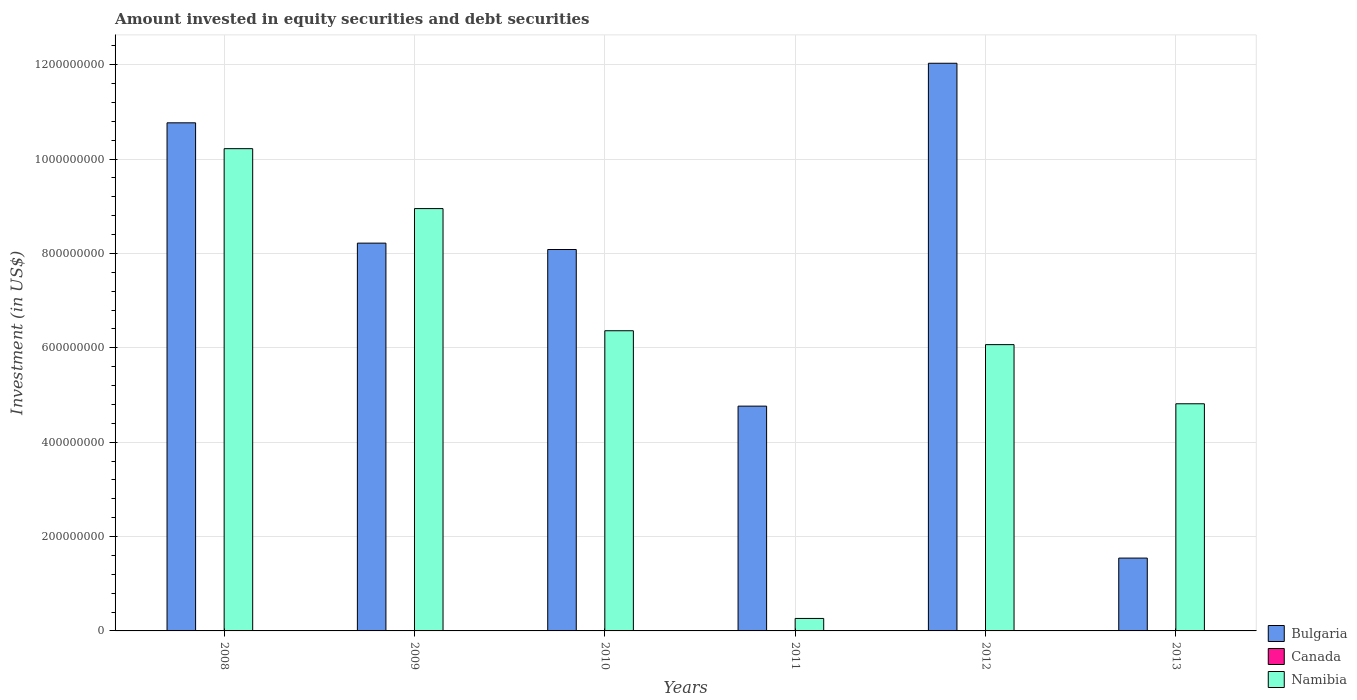How many different coloured bars are there?
Your answer should be very brief. 2. How many groups of bars are there?
Offer a very short reply. 6. Are the number of bars per tick equal to the number of legend labels?
Provide a succinct answer. No. How many bars are there on the 4th tick from the left?
Keep it short and to the point. 2. What is the label of the 1st group of bars from the left?
Offer a very short reply. 2008. Across all years, what is the maximum amount invested in equity securities and debt securities in Bulgaria?
Offer a terse response. 1.20e+09. Across all years, what is the minimum amount invested in equity securities and debt securities in Bulgaria?
Offer a very short reply. 1.54e+08. In which year was the amount invested in equity securities and debt securities in Bulgaria maximum?
Your answer should be compact. 2012. What is the total amount invested in equity securities and debt securities in Bulgaria in the graph?
Keep it short and to the point. 4.54e+09. What is the difference between the amount invested in equity securities and debt securities in Namibia in 2009 and that in 2012?
Your response must be concise. 2.88e+08. What is the difference between the amount invested in equity securities and debt securities in Bulgaria in 2011 and the amount invested in equity securities and debt securities in Canada in 2013?
Give a very brief answer. 4.76e+08. What is the average amount invested in equity securities and debt securities in Bulgaria per year?
Ensure brevity in your answer.  7.57e+08. In the year 2008, what is the difference between the amount invested in equity securities and debt securities in Namibia and amount invested in equity securities and debt securities in Bulgaria?
Your response must be concise. -5.48e+07. What is the ratio of the amount invested in equity securities and debt securities in Namibia in 2008 to that in 2011?
Offer a terse response. 38.63. What is the difference between the highest and the second highest amount invested in equity securities and debt securities in Namibia?
Keep it short and to the point. 1.27e+08. What is the difference between the highest and the lowest amount invested in equity securities and debt securities in Bulgaria?
Make the answer very short. 1.05e+09. Is the sum of the amount invested in equity securities and debt securities in Namibia in 2011 and 2013 greater than the maximum amount invested in equity securities and debt securities in Bulgaria across all years?
Give a very brief answer. No. Are all the bars in the graph horizontal?
Provide a short and direct response. No. How many years are there in the graph?
Offer a very short reply. 6. Are the values on the major ticks of Y-axis written in scientific E-notation?
Give a very brief answer. No. Where does the legend appear in the graph?
Offer a very short reply. Bottom right. What is the title of the graph?
Offer a very short reply. Amount invested in equity securities and debt securities. Does "Morocco" appear as one of the legend labels in the graph?
Your answer should be compact. No. What is the label or title of the Y-axis?
Give a very brief answer. Investment (in US$). What is the Investment (in US$) in Bulgaria in 2008?
Give a very brief answer. 1.08e+09. What is the Investment (in US$) in Canada in 2008?
Make the answer very short. 0. What is the Investment (in US$) of Namibia in 2008?
Make the answer very short. 1.02e+09. What is the Investment (in US$) of Bulgaria in 2009?
Your response must be concise. 8.22e+08. What is the Investment (in US$) of Namibia in 2009?
Give a very brief answer. 8.95e+08. What is the Investment (in US$) of Bulgaria in 2010?
Make the answer very short. 8.08e+08. What is the Investment (in US$) of Namibia in 2010?
Offer a terse response. 6.36e+08. What is the Investment (in US$) in Bulgaria in 2011?
Provide a short and direct response. 4.76e+08. What is the Investment (in US$) in Namibia in 2011?
Your answer should be compact. 2.65e+07. What is the Investment (in US$) of Bulgaria in 2012?
Your response must be concise. 1.20e+09. What is the Investment (in US$) of Canada in 2012?
Provide a short and direct response. 0. What is the Investment (in US$) of Namibia in 2012?
Offer a very short reply. 6.07e+08. What is the Investment (in US$) of Bulgaria in 2013?
Make the answer very short. 1.54e+08. What is the Investment (in US$) in Namibia in 2013?
Keep it short and to the point. 4.81e+08. Across all years, what is the maximum Investment (in US$) of Bulgaria?
Provide a short and direct response. 1.20e+09. Across all years, what is the maximum Investment (in US$) in Namibia?
Provide a short and direct response. 1.02e+09. Across all years, what is the minimum Investment (in US$) in Bulgaria?
Ensure brevity in your answer.  1.54e+08. Across all years, what is the minimum Investment (in US$) in Namibia?
Make the answer very short. 2.65e+07. What is the total Investment (in US$) of Bulgaria in the graph?
Give a very brief answer. 4.54e+09. What is the total Investment (in US$) in Namibia in the graph?
Your answer should be very brief. 3.67e+09. What is the difference between the Investment (in US$) of Bulgaria in 2008 and that in 2009?
Keep it short and to the point. 2.55e+08. What is the difference between the Investment (in US$) of Namibia in 2008 and that in 2009?
Your response must be concise. 1.27e+08. What is the difference between the Investment (in US$) in Bulgaria in 2008 and that in 2010?
Make the answer very short. 2.68e+08. What is the difference between the Investment (in US$) in Namibia in 2008 and that in 2010?
Provide a succinct answer. 3.86e+08. What is the difference between the Investment (in US$) of Bulgaria in 2008 and that in 2011?
Keep it short and to the point. 6.00e+08. What is the difference between the Investment (in US$) of Namibia in 2008 and that in 2011?
Your answer should be very brief. 9.96e+08. What is the difference between the Investment (in US$) of Bulgaria in 2008 and that in 2012?
Provide a short and direct response. -1.26e+08. What is the difference between the Investment (in US$) in Namibia in 2008 and that in 2012?
Keep it short and to the point. 4.15e+08. What is the difference between the Investment (in US$) of Bulgaria in 2008 and that in 2013?
Make the answer very short. 9.22e+08. What is the difference between the Investment (in US$) in Namibia in 2008 and that in 2013?
Your answer should be very brief. 5.41e+08. What is the difference between the Investment (in US$) of Bulgaria in 2009 and that in 2010?
Your answer should be compact. 1.35e+07. What is the difference between the Investment (in US$) of Namibia in 2009 and that in 2010?
Offer a terse response. 2.59e+08. What is the difference between the Investment (in US$) in Bulgaria in 2009 and that in 2011?
Your response must be concise. 3.45e+08. What is the difference between the Investment (in US$) in Namibia in 2009 and that in 2011?
Your answer should be very brief. 8.69e+08. What is the difference between the Investment (in US$) in Bulgaria in 2009 and that in 2012?
Give a very brief answer. -3.81e+08. What is the difference between the Investment (in US$) of Namibia in 2009 and that in 2012?
Provide a short and direct response. 2.88e+08. What is the difference between the Investment (in US$) of Bulgaria in 2009 and that in 2013?
Your response must be concise. 6.67e+08. What is the difference between the Investment (in US$) in Namibia in 2009 and that in 2013?
Offer a very short reply. 4.14e+08. What is the difference between the Investment (in US$) of Bulgaria in 2010 and that in 2011?
Your answer should be compact. 3.32e+08. What is the difference between the Investment (in US$) of Namibia in 2010 and that in 2011?
Make the answer very short. 6.10e+08. What is the difference between the Investment (in US$) of Bulgaria in 2010 and that in 2012?
Give a very brief answer. -3.95e+08. What is the difference between the Investment (in US$) of Namibia in 2010 and that in 2012?
Ensure brevity in your answer.  2.94e+07. What is the difference between the Investment (in US$) in Bulgaria in 2010 and that in 2013?
Provide a succinct answer. 6.54e+08. What is the difference between the Investment (in US$) in Namibia in 2010 and that in 2013?
Your answer should be very brief. 1.55e+08. What is the difference between the Investment (in US$) in Bulgaria in 2011 and that in 2012?
Make the answer very short. -7.27e+08. What is the difference between the Investment (in US$) of Namibia in 2011 and that in 2012?
Provide a succinct answer. -5.80e+08. What is the difference between the Investment (in US$) of Bulgaria in 2011 and that in 2013?
Offer a very short reply. 3.22e+08. What is the difference between the Investment (in US$) in Namibia in 2011 and that in 2013?
Your answer should be compact. -4.55e+08. What is the difference between the Investment (in US$) in Bulgaria in 2012 and that in 2013?
Offer a very short reply. 1.05e+09. What is the difference between the Investment (in US$) of Namibia in 2012 and that in 2013?
Your answer should be compact. 1.25e+08. What is the difference between the Investment (in US$) in Bulgaria in 2008 and the Investment (in US$) in Namibia in 2009?
Make the answer very short. 1.82e+08. What is the difference between the Investment (in US$) of Bulgaria in 2008 and the Investment (in US$) of Namibia in 2010?
Provide a succinct answer. 4.41e+08. What is the difference between the Investment (in US$) in Bulgaria in 2008 and the Investment (in US$) in Namibia in 2011?
Ensure brevity in your answer.  1.05e+09. What is the difference between the Investment (in US$) of Bulgaria in 2008 and the Investment (in US$) of Namibia in 2012?
Your answer should be very brief. 4.70e+08. What is the difference between the Investment (in US$) in Bulgaria in 2008 and the Investment (in US$) in Namibia in 2013?
Provide a short and direct response. 5.95e+08. What is the difference between the Investment (in US$) in Bulgaria in 2009 and the Investment (in US$) in Namibia in 2010?
Your answer should be compact. 1.86e+08. What is the difference between the Investment (in US$) of Bulgaria in 2009 and the Investment (in US$) of Namibia in 2011?
Provide a succinct answer. 7.95e+08. What is the difference between the Investment (in US$) in Bulgaria in 2009 and the Investment (in US$) in Namibia in 2012?
Provide a short and direct response. 2.15e+08. What is the difference between the Investment (in US$) of Bulgaria in 2009 and the Investment (in US$) of Namibia in 2013?
Offer a very short reply. 3.40e+08. What is the difference between the Investment (in US$) in Bulgaria in 2010 and the Investment (in US$) in Namibia in 2011?
Your response must be concise. 7.82e+08. What is the difference between the Investment (in US$) in Bulgaria in 2010 and the Investment (in US$) in Namibia in 2012?
Provide a succinct answer. 2.02e+08. What is the difference between the Investment (in US$) in Bulgaria in 2010 and the Investment (in US$) in Namibia in 2013?
Keep it short and to the point. 3.27e+08. What is the difference between the Investment (in US$) of Bulgaria in 2011 and the Investment (in US$) of Namibia in 2012?
Your response must be concise. -1.30e+08. What is the difference between the Investment (in US$) of Bulgaria in 2011 and the Investment (in US$) of Namibia in 2013?
Give a very brief answer. -5.03e+06. What is the difference between the Investment (in US$) in Bulgaria in 2012 and the Investment (in US$) in Namibia in 2013?
Your answer should be very brief. 7.22e+08. What is the average Investment (in US$) in Bulgaria per year?
Provide a succinct answer. 7.57e+08. What is the average Investment (in US$) in Namibia per year?
Offer a terse response. 6.11e+08. In the year 2008, what is the difference between the Investment (in US$) of Bulgaria and Investment (in US$) of Namibia?
Offer a very short reply. 5.48e+07. In the year 2009, what is the difference between the Investment (in US$) in Bulgaria and Investment (in US$) in Namibia?
Your answer should be compact. -7.32e+07. In the year 2010, what is the difference between the Investment (in US$) in Bulgaria and Investment (in US$) in Namibia?
Your answer should be compact. 1.72e+08. In the year 2011, what is the difference between the Investment (in US$) in Bulgaria and Investment (in US$) in Namibia?
Provide a succinct answer. 4.50e+08. In the year 2012, what is the difference between the Investment (in US$) in Bulgaria and Investment (in US$) in Namibia?
Keep it short and to the point. 5.96e+08. In the year 2013, what is the difference between the Investment (in US$) of Bulgaria and Investment (in US$) of Namibia?
Your answer should be very brief. -3.27e+08. What is the ratio of the Investment (in US$) of Bulgaria in 2008 to that in 2009?
Provide a short and direct response. 1.31. What is the ratio of the Investment (in US$) of Namibia in 2008 to that in 2009?
Make the answer very short. 1.14. What is the ratio of the Investment (in US$) of Bulgaria in 2008 to that in 2010?
Give a very brief answer. 1.33. What is the ratio of the Investment (in US$) of Namibia in 2008 to that in 2010?
Keep it short and to the point. 1.61. What is the ratio of the Investment (in US$) of Bulgaria in 2008 to that in 2011?
Offer a terse response. 2.26. What is the ratio of the Investment (in US$) in Namibia in 2008 to that in 2011?
Provide a succinct answer. 38.63. What is the ratio of the Investment (in US$) in Bulgaria in 2008 to that in 2012?
Offer a terse response. 0.9. What is the ratio of the Investment (in US$) in Namibia in 2008 to that in 2012?
Make the answer very short. 1.68. What is the ratio of the Investment (in US$) of Bulgaria in 2008 to that in 2013?
Provide a succinct answer. 6.98. What is the ratio of the Investment (in US$) in Namibia in 2008 to that in 2013?
Ensure brevity in your answer.  2.12. What is the ratio of the Investment (in US$) of Bulgaria in 2009 to that in 2010?
Offer a very short reply. 1.02. What is the ratio of the Investment (in US$) in Namibia in 2009 to that in 2010?
Keep it short and to the point. 1.41. What is the ratio of the Investment (in US$) in Bulgaria in 2009 to that in 2011?
Ensure brevity in your answer.  1.73. What is the ratio of the Investment (in US$) in Namibia in 2009 to that in 2011?
Keep it short and to the point. 33.83. What is the ratio of the Investment (in US$) of Bulgaria in 2009 to that in 2012?
Make the answer very short. 0.68. What is the ratio of the Investment (in US$) in Namibia in 2009 to that in 2012?
Keep it short and to the point. 1.48. What is the ratio of the Investment (in US$) in Bulgaria in 2009 to that in 2013?
Your response must be concise. 5.32. What is the ratio of the Investment (in US$) in Namibia in 2009 to that in 2013?
Offer a terse response. 1.86. What is the ratio of the Investment (in US$) in Bulgaria in 2010 to that in 2011?
Your answer should be compact. 1.7. What is the ratio of the Investment (in US$) in Namibia in 2010 to that in 2011?
Your response must be concise. 24.05. What is the ratio of the Investment (in US$) of Bulgaria in 2010 to that in 2012?
Offer a very short reply. 0.67. What is the ratio of the Investment (in US$) in Namibia in 2010 to that in 2012?
Ensure brevity in your answer.  1.05. What is the ratio of the Investment (in US$) of Bulgaria in 2010 to that in 2013?
Provide a short and direct response. 5.24. What is the ratio of the Investment (in US$) of Namibia in 2010 to that in 2013?
Provide a short and direct response. 1.32. What is the ratio of the Investment (in US$) of Bulgaria in 2011 to that in 2012?
Keep it short and to the point. 0.4. What is the ratio of the Investment (in US$) of Namibia in 2011 to that in 2012?
Your answer should be compact. 0.04. What is the ratio of the Investment (in US$) of Bulgaria in 2011 to that in 2013?
Offer a very short reply. 3.09. What is the ratio of the Investment (in US$) in Namibia in 2011 to that in 2013?
Offer a very short reply. 0.06. What is the ratio of the Investment (in US$) in Bulgaria in 2012 to that in 2013?
Offer a terse response. 7.79. What is the ratio of the Investment (in US$) of Namibia in 2012 to that in 2013?
Your answer should be very brief. 1.26. What is the difference between the highest and the second highest Investment (in US$) in Bulgaria?
Keep it short and to the point. 1.26e+08. What is the difference between the highest and the second highest Investment (in US$) in Namibia?
Your response must be concise. 1.27e+08. What is the difference between the highest and the lowest Investment (in US$) of Bulgaria?
Provide a succinct answer. 1.05e+09. What is the difference between the highest and the lowest Investment (in US$) in Namibia?
Your answer should be very brief. 9.96e+08. 